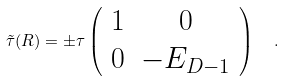<formula> <loc_0><loc_0><loc_500><loc_500>\tilde { \tau } ( R ) = \pm \tau \left ( \begin{array} { c c } 1 & 0 \\ 0 & - E _ { D - 1 } \\ \end{array} \right ) \ \ .</formula> 